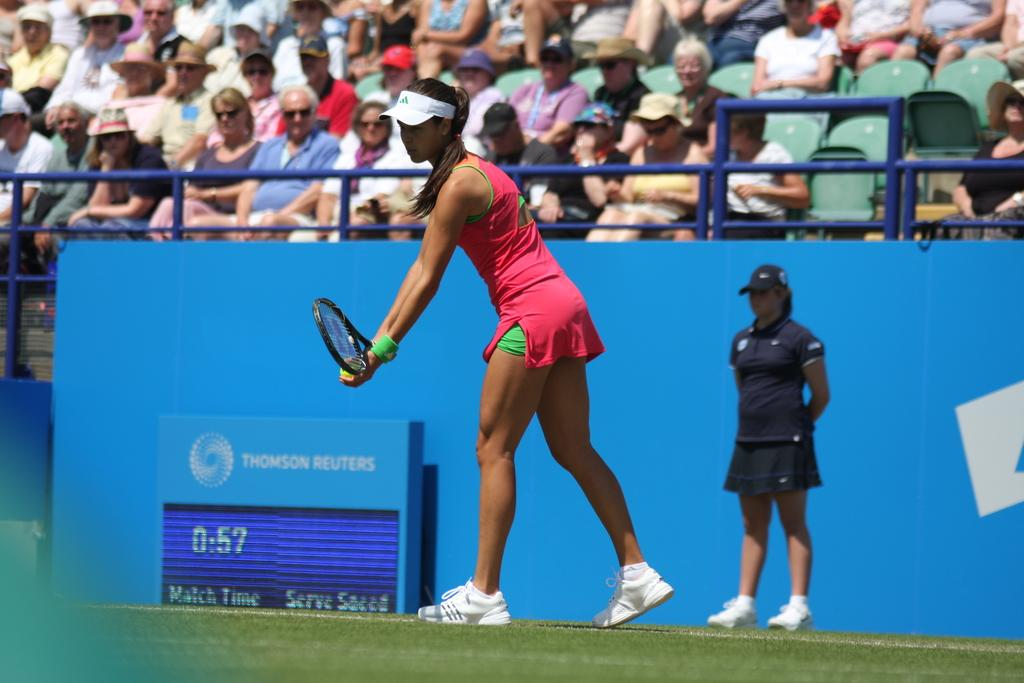What are the people in the image doing? The people in the image are sitting. Can you describe any objects being held by the people? One of the women is holding a shuttle bat. What type of twig can be seen in the image? There is no twig present in the image. What kind of beef dish is being served in the image? There is no beef dish present in the image. 